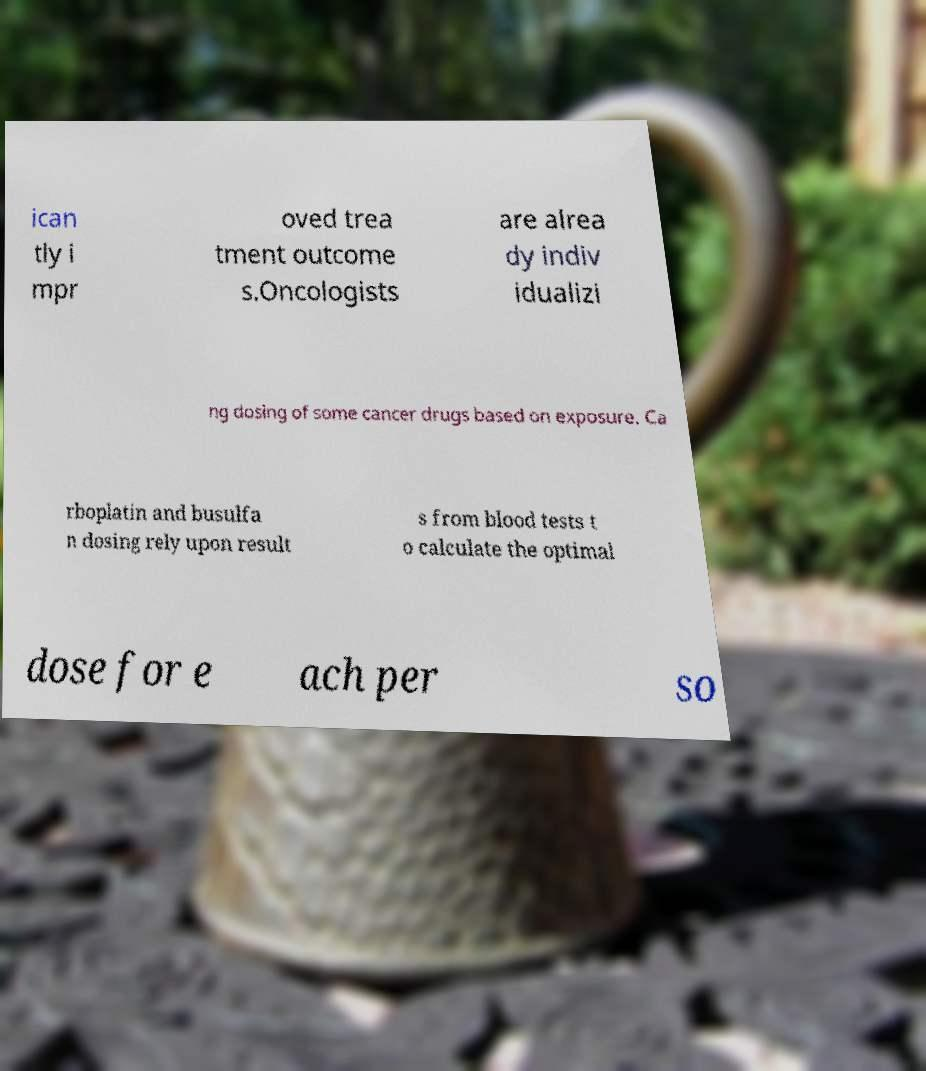Please read and relay the text visible in this image. What does it say? ican tly i mpr oved trea tment outcome s.Oncologists are alrea dy indiv idualizi ng dosing of some cancer drugs based on exposure. Ca rboplatin and busulfa n dosing rely upon result s from blood tests t o calculate the optimal dose for e ach per so 